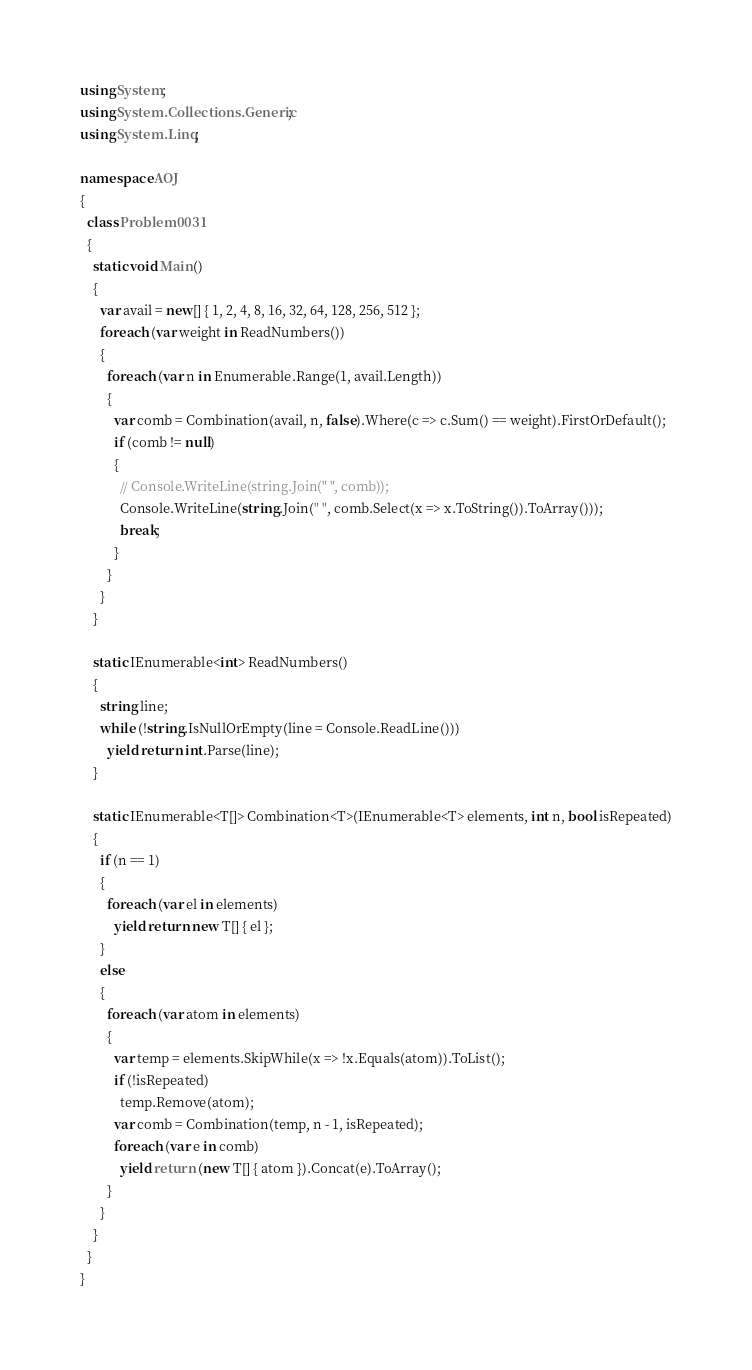<code> <loc_0><loc_0><loc_500><loc_500><_C#_>using System;
using System.Collections.Generic;
using System.Linq;

namespace AOJ
{
  class Problem0031
  {
    static void Main()
    {
      var avail = new[] { 1, 2, 4, 8, 16, 32, 64, 128, 256, 512 };
      foreach (var weight in ReadNumbers())
      {
        foreach (var n in Enumerable.Range(1, avail.Length))
        {
          var comb = Combination(avail, n, false).Where(c => c.Sum() == weight).FirstOrDefault();
          if (comb != null)
          {
            // Console.WriteLine(string.Join(" ", comb));
            Console.WriteLine(string.Join(" ", comb.Select(x => x.ToString()).ToArray()));
            break;
          }
        }
      }
    }

    static IEnumerable<int> ReadNumbers()
    {
      string line;
      while (!string.IsNullOrEmpty(line = Console.ReadLine()))
        yield return int.Parse(line);
    }

    static IEnumerable<T[]> Combination<T>(IEnumerable<T> elements, int n, bool isRepeated)
    {
      if (n == 1)
      {
        foreach (var el in elements)
          yield return new T[] { el };
      }
      else
      {
        foreach (var atom in elements)
        {
          var temp = elements.SkipWhile(x => !x.Equals(atom)).ToList();
          if (!isRepeated)
            temp.Remove(atom);
          var comb = Combination(temp, n - 1, isRepeated);
          foreach (var e in comb)
            yield return (new T[] { atom }).Concat(e).ToArray();
        }
      }
    }
  }
}</code> 